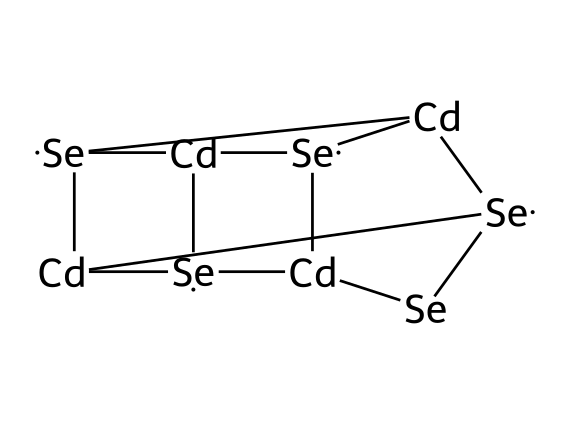What is the central metal atom in this quantum dot structure? The structure shows the presence of cadmium atoms, which serve as the central metal in the formula represented by [Cd].
Answer: cadmium How many selenium atoms are present in this quantum dot? By analyzing the structure, there are five instances of the selenium representation [Se], indicating a total of five selenium atoms in the quantum dot.
Answer: five What type of bonding can be observed in this quantum dot? The presence of interconnected cadmium and selenium atoms suggests metallic and covalent bonding, as cadmium serves as a metal and selenium as a non-metal pair forming a semiconductor network.
Answer: metallic and covalent How many distinct cadmium atoms are in the structure? The chemical notation shows that there are a total of five distinct references to cadmium atoms in the SMILES representation, indicating their consistent presence throughout the quantum dot.
Answer: five What role do quantum dots like this one typically play in technology? Quantum dots, including this one with cadmium and selenium, are widely utilized in applications like displays, solar cells, and medical imaging due to their unique optical properties.
Answer: displays and imaging What geometric shape do you associate with the structure of a quantum dot? The arrangement of atoms in the SMILES representation corresponds to a spherical shape, akin to that of a basketball, reflecting how quantum dots are nanometer-sized semiconductor particles.
Answer: spherical 